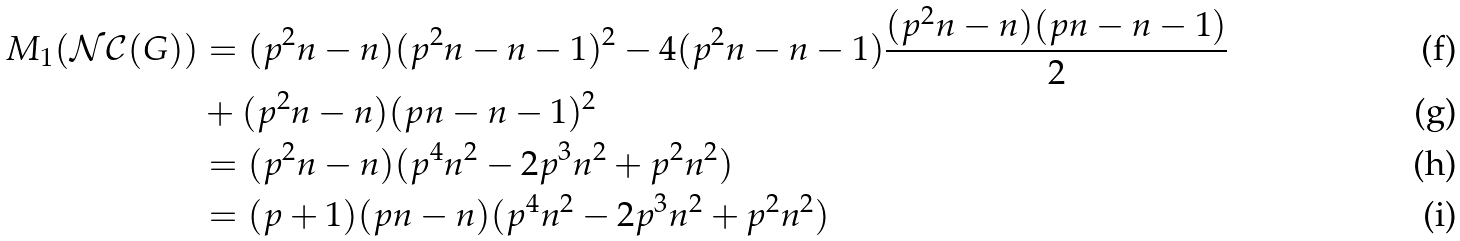<formula> <loc_0><loc_0><loc_500><loc_500>M _ { 1 } ( \mathcal { N C } ( G ) ) & = ( p ^ { 2 } n - n ) ( p ^ { 2 } n - n - 1 ) ^ { 2 } - 4 ( p ^ { 2 } n - n - 1 ) \frac { ( p ^ { 2 } n - n ) ( p n - n - 1 ) } { 2 } \\ & + ( p ^ { 2 } n - n ) ( p n - n - 1 ) ^ { 2 } \\ & = ( p ^ { 2 } n - n ) ( p ^ { 4 } n ^ { 2 } - 2 p ^ { 3 } n ^ { 2 } + p ^ { 2 } n ^ { 2 } ) \\ & = ( p + 1 ) ( p n - n ) ( p ^ { 4 } n ^ { 2 } - 2 p ^ { 3 } n ^ { 2 } + p ^ { 2 } n ^ { 2 } )</formula> 